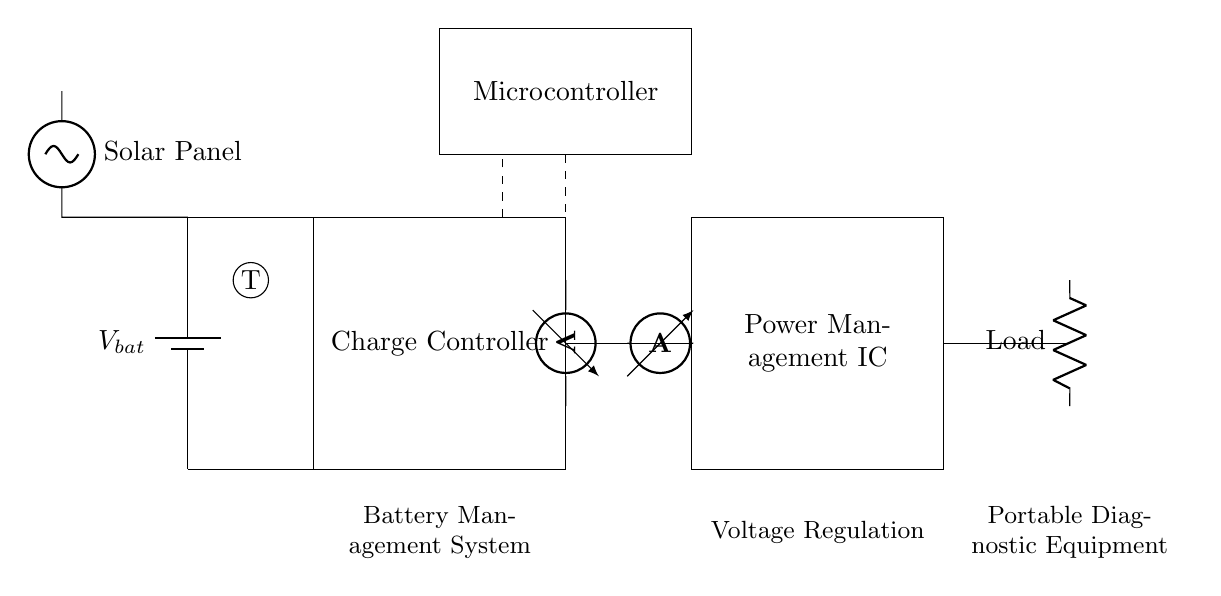What type of battery is used in this circuit? The diagram features a generic battery symbol representing any common battery type used in portable applications, labeled as V bat. There isn’t a specific type indicated, so it's open to interpretation based on the application.
Answer: Battery What is the function of the charge controller? The charge controller manages the charging process of the battery, ensuring that it is charged efficiently and safely, protecting from overcharging which could damage the battery.
Answer: Manage charging What is the role of the microcontroller in this system? The microcontroller coordinates the operation of the various components within the circuit, implementing control strategies for charging, monitoring sensor data, and communicating with other systems.
Answer: Coordination Which component provides power to the load? The load, representing the diagnostic equipment, is powered by the battery through the power management integrated circuit, which regulates the voltage and current to the load.
Answer: Power management IC How does the solar panel interact with the battery system? The solar panel generates electrical energy, which is routed to the battery and the charge controller, allowing for sustainable charging of the battery when sunlight is available, supporting portable applications.
Answer: Charges battery What types of sensors are present in this circuit, and what do they measure? The circuit features a current sensor, a voltage sensor, and a temperature sensor. The current sensor measures flow of electric current, the voltage sensor monitors voltage levels, and the temperature sensor ensures that the battery operates within safe temperature ranges.
Answer: Current, voltage, temperature What is the significance of the dashed lines in the schematic? Dashed lines typically indicate control signals or connections that are not power connections but manage how the system behaves, showing the communication between the microcontroller and other components for operations like monitoring and regulation.
Answer: Control connections 